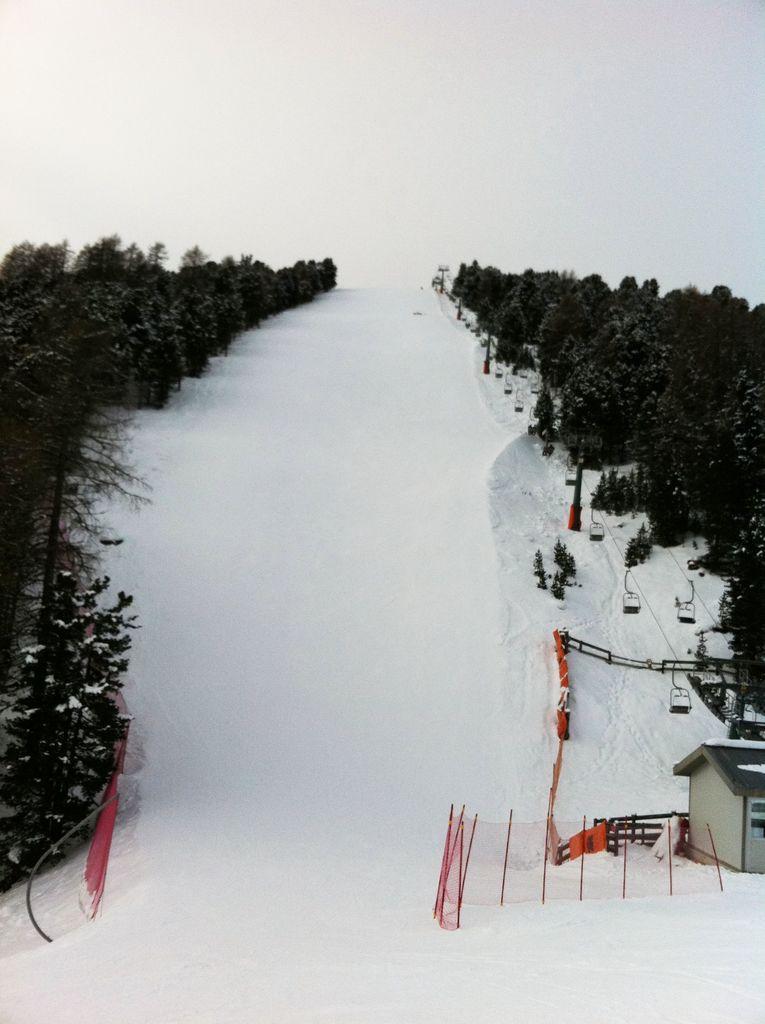Describe this image in one or two sentences. In this picture we can observe some snow on the land. There is a red color fence and cabin on the right side. We can observe trees. The background is in white color. 